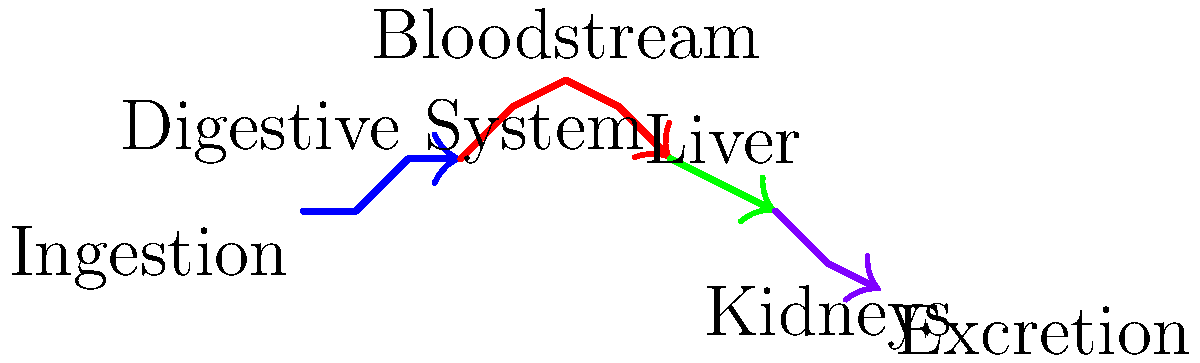As a medical student, you understand the importance of tracking a medication's path through the body. Based on the diagram, which organ system is responsible for the initial absorption of an orally administered medication into the bloodstream? To answer this question, let's follow the path of the medication step-by-step:

1. The diagram starts at the point labeled "Ingestion," indicating that the medication is taken orally.

2. The blue path represents the digestive system, which is the first system the medication encounters after ingestion.

3. The digestive system path leads directly into the red path, which represents the bloodstream.

4. This transition from the digestive system to the bloodstream indicates that the digestive system is responsible for absorbing the medication and transferring it into the blood.

5. After entering the bloodstream, the medication travels to other organs like the liver (green path) and kidneys (purple path) for further processing and eventual excretion.

6. The question specifically asks about the initial absorption into the bloodstream, which occurs in the digestive system before the medication reaches any other organ systems.

Therefore, based on this diagram and the typical path of orally administered medications, the digestive system is responsible for the initial absorption of the medication into the bloodstream.
Answer: Digestive system 